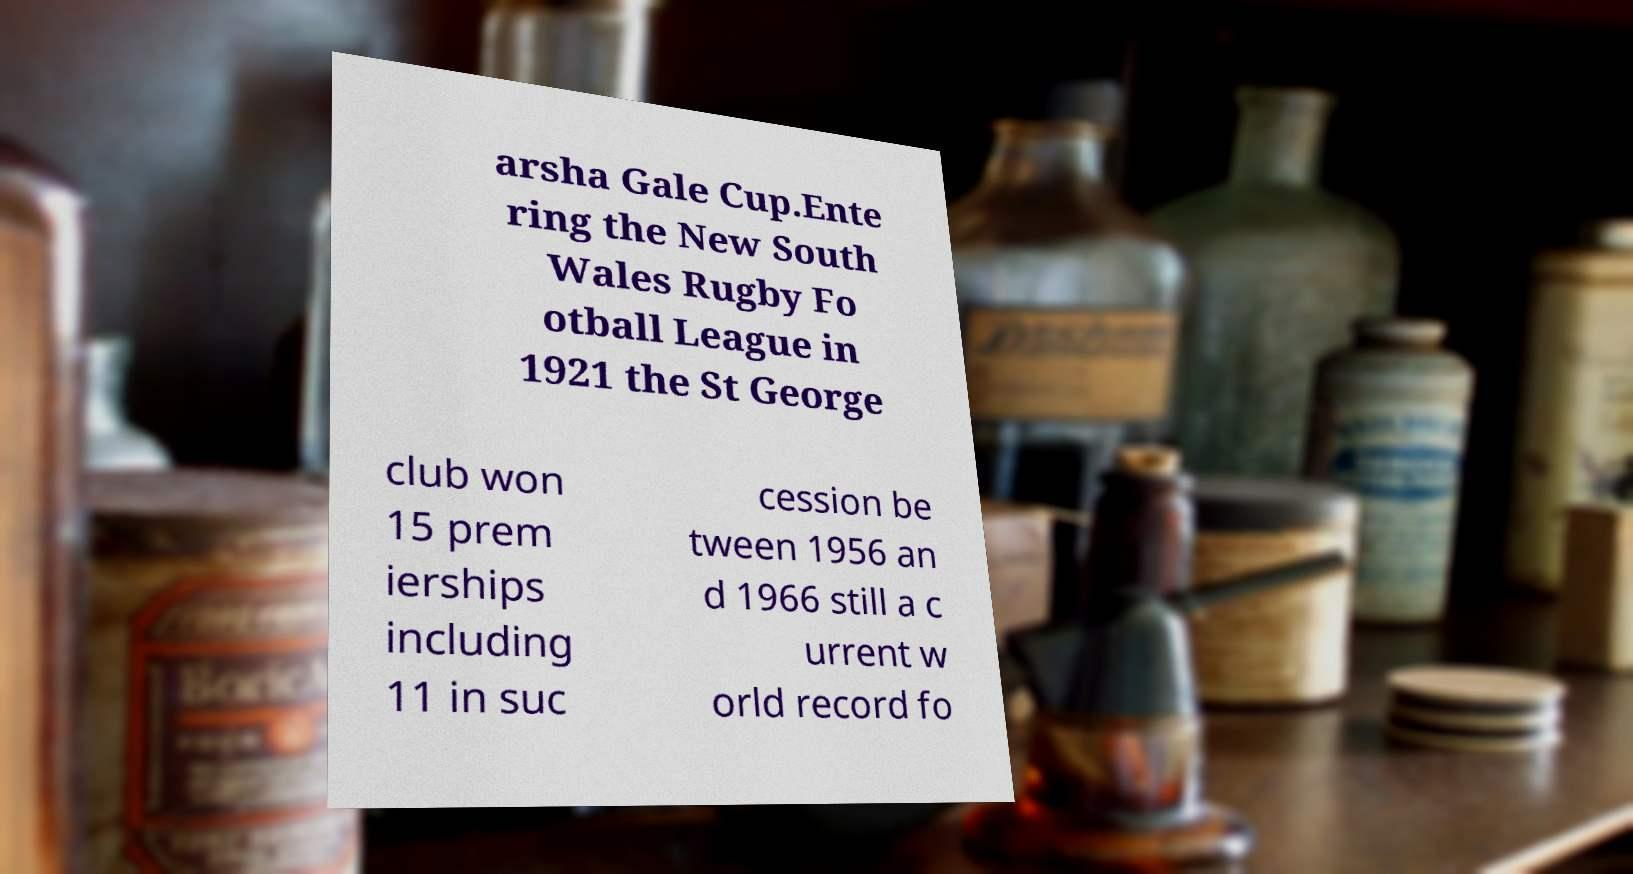Please identify and transcribe the text found in this image. arsha Gale Cup.Ente ring the New South Wales Rugby Fo otball League in 1921 the St George club won 15 prem ierships including 11 in suc cession be tween 1956 an d 1966 still a c urrent w orld record fo 